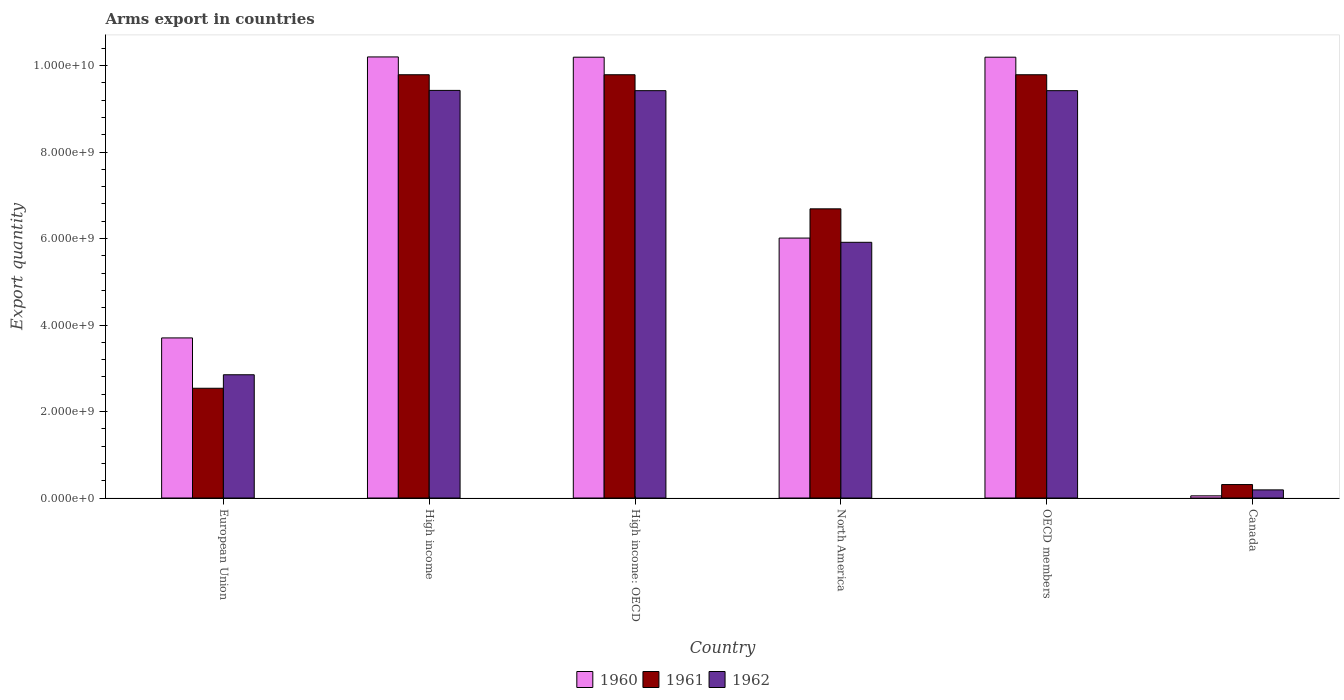How many groups of bars are there?
Offer a terse response. 6. Are the number of bars on each tick of the X-axis equal?
Provide a succinct answer. Yes. How many bars are there on the 2nd tick from the right?
Provide a succinct answer. 3. What is the label of the 3rd group of bars from the left?
Your answer should be compact. High income: OECD. In how many cases, is the number of bars for a given country not equal to the number of legend labels?
Provide a short and direct response. 0. What is the total arms export in 1961 in High income?
Offer a very short reply. 9.79e+09. Across all countries, what is the maximum total arms export in 1962?
Your answer should be compact. 9.43e+09. Across all countries, what is the minimum total arms export in 1961?
Your response must be concise. 3.11e+08. What is the total total arms export in 1960 in the graph?
Give a very brief answer. 4.04e+1. What is the difference between the total arms export in 1962 in High income: OECD and that in OECD members?
Provide a succinct answer. 0. What is the difference between the total arms export in 1960 in High income: OECD and the total arms export in 1961 in High income?
Offer a terse response. 4.06e+08. What is the average total arms export in 1960 per country?
Your answer should be compact. 6.73e+09. What is the difference between the total arms export of/in 1962 and total arms export of/in 1960 in North America?
Keep it short and to the point. -9.80e+07. In how many countries, is the total arms export in 1961 greater than 4400000000?
Ensure brevity in your answer.  4. What is the ratio of the total arms export in 1961 in High income to that in High income: OECD?
Give a very brief answer. 1. Is the difference between the total arms export in 1962 in High income and North America greater than the difference between the total arms export in 1960 in High income and North America?
Ensure brevity in your answer.  No. What is the difference between the highest and the lowest total arms export in 1960?
Offer a terse response. 1.02e+1. In how many countries, is the total arms export in 1962 greater than the average total arms export in 1962 taken over all countries?
Make the answer very short. 3. Is the sum of the total arms export in 1960 in European Union and OECD members greater than the maximum total arms export in 1962 across all countries?
Offer a terse response. Yes. What does the 3rd bar from the right in High income: OECD represents?
Keep it short and to the point. 1960. How many bars are there?
Your answer should be compact. 18. Does the graph contain any zero values?
Make the answer very short. No. Does the graph contain grids?
Offer a very short reply. No. Where does the legend appear in the graph?
Your response must be concise. Bottom center. How many legend labels are there?
Offer a very short reply. 3. What is the title of the graph?
Provide a short and direct response. Arms export in countries. Does "1991" appear as one of the legend labels in the graph?
Provide a short and direct response. No. What is the label or title of the Y-axis?
Your answer should be compact. Export quantity. What is the Export quantity in 1960 in European Union?
Provide a succinct answer. 3.70e+09. What is the Export quantity in 1961 in European Union?
Make the answer very short. 2.54e+09. What is the Export quantity in 1962 in European Union?
Provide a succinct answer. 2.85e+09. What is the Export quantity of 1960 in High income?
Provide a succinct answer. 1.02e+1. What is the Export quantity of 1961 in High income?
Make the answer very short. 9.79e+09. What is the Export quantity of 1962 in High income?
Make the answer very short. 9.43e+09. What is the Export quantity of 1960 in High income: OECD?
Your response must be concise. 1.02e+1. What is the Export quantity of 1961 in High income: OECD?
Provide a short and direct response. 9.79e+09. What is the Export quantity in 1962 in High income: OECD?
Make the answer very short. 9.42e+09. What is the Export quantity in 1960 in North America?
Your response must be concise. 6.01e+09. What is the Export quantity in 1961 in North America?
Provide a short and direct response. 6.69e+09. What is the Export quantity of 1962 in North America?
Provide a succinct answer. 5.91e+09. What is the Export quantity in 1960 in OECD members?
Your response must be concise. 1.02e+1. What is the Export quantity in 1961 in OECD members?
Your response must be concise. 9.79e+09. What is the Export quantity in 1962 in OECD members?
Keep it short and to the point. 9.42e+09. What is the Export quantity of 1960 in Canada?
Make the answer very short. 5.00e+07. What is the Export quantity in 1961 in Canada?
Ensure brevity in your answer.  3.11e+08. What is the Export quantity in 1962 in Canada?
Provide a succinct answer. 1.88e+08. Across all countries, what is the maximum Export quantity in 1960?
Offer a terse response. 1.02e+1. Across all countries, what is the maximum Export quantity of 1961?
Provide a succinct answer. 9.79e+09. Across all countries, what is the maximum Export quantity in 1962?
Give a very brief answer. 9.43e+09. Across all countries, what is the minimum Export quantity in 1961?
Ensure brevity in your answer.  3.11e+08. Across all countries, what is the minimum Export quantity of 1962?
Offer a terse response. 1.88e+08. What is the total Export quantity of 1960 in the graph?
Your answer should be compact. 4.04e+1. What is the total Export quantity in 1961 in the graph?
Provide a succinct answer. 3.89e+1. What is the total Export quantity of 1962 in the graph?
Ensure brevity in your answer.  3.72e+1. What is the difference between the Export quantity in 1960 in European Union and that in High income?
Make the answer very short. -6.50e+09. What is the difference between the Export quantity of 1961 in European Union and that in High income?
Keep it short and to the point. -7.25e+09. What is the difference between the Export quantity in 1962 in European Union and that in High income?
Provide a short and direct response. -6.58e+09. What is the difference between the Export quantity of 1960 in European Union and that in High income: OECD?
Your response must be concise. -6.49e+09. What is the difference between the Export quantity in 1961 in European Union and that in High income: OECD?
Your response must be concise. -7.25e+09. What is the difference between the Export quantity of 1962 in European Union and that in High income: OECD?
Provide a succinct answer. -6.57e+09. What is the difference between the Export quantity in 1960 in European Union and that in North America?
Your answer should be compact. -2.31e+09. What is the difference between the Export quantity in 1961 in European Union and that in North America?
Provide a short and direct response. -4.15e+09. What is the difference between the Export quantity in 1962 in European Union and that in North America?
Provide a short and direct response. -3.06e+09. What is the difference between the Export quantity in 1960 in European Union and that in OECD members?
Your answer should be very brief. -6.49e+09. What is the difference between the Export quantity of 1961 in European Union and that in OECD members?
Your answer should be very brief. -7.25e+09. What is the difference between the Export quantity in 1962 in European Union and that in OECD members?
Provide a short and direct response. -6.57e+09. What is the difference between the Export quantity in 1960 in European Union and that in Canada?
Provide a short and direct response. 3.65e+09. What is the difference between the Export quantity in 1961 in European Union and that in Canada?
Your response must be concise. 2.23e+09. What is the difference between the Export quantity in 1962 in European Union and that in Canada?
Ensure brevity in your answer.  2.66e+09. What is the difference between the Export quantity in 1960 in High income and that in High income: OECD?
Make the answer very short. 6.00e+06. What is the difference between the Export quantity in 1961 in High income and that in High income: OECD?
Offer a very short reply. 0. What is the difference between the Export quantity of 1960 in High income and that in North America?
Make the answer very short. 4.19e+09. What is the difference between the Export quantity in 1961 in High income and that in North America?
Offer a very short reply. 3.10e+09. What is the difference between the Export quantity in 1962 in High income and that in North America?
Keep it short and to the point. 3.51e+09. What is the difference between the Export quantity in 1961 in High income and that in OECD members?
Your answer should be compact. 0. What is the difference between the Export quantity in 1962 in High income and that in OECD members?
Ensure brevity in your answer.  6.00e+06. What is the difference between the Export quantity of 1960 in High income and that in Canada?
Your response must be concise. 1.02e+1. What is the difference between the Export quantity of 1961 in High income and that in Canada?
Ensure brevity in your answer.  9.48e+09. What is the difference between the Export quantity of 1962 in High income and that in Canada?
Provide a short and direct response. 9.24e+09. What is the difference between the Export quantity of 1960 in High income: OECD and that in North America?
Keep it short and to the point. 4.18e+09. What is the difference between the Export quantity in 1961 in High income: OECD and that in North America?
Keep it short and to the point. 3.10e+09. What is the difference between the Export quantity of 1962 in High income: OECD and that in North America?
Your answer should be very brief. 3.51e+09. What is the difference between the Export quantity of 1960 in High income: OECD and that in Canada?
Provide a succinct answer. 1.01e+1. What is the difference between the Export quantity in 1961 in High income: OECD and that in Canada?
Offer a very short reply. 9.48e+09. What is the difference between the Export quantity of 1962 in High income: OECD and that in Canada?
Offer a terse response. 9.23e+09. What is the difference between the Export quantity of 1960 in North America and that in OECD members?
Offer a very short reply. -4.18e+09. What is the difference between the Export quantity in 1961 in North America and that in OECD members?
Your answer should be compact. -3.10e+09. What is the difference between the Export quantity of 1962 in North America and that in OECD members?
Offer a terse response. -3.51e+09. What is the difference between the Export quantity in 1960 in North America and that in Canada?
Make the answer very short. 5.96e+09. What is the difference between the Export quantity in 1961 in North America and that in Canada?
Your answer should be very brief. 6.38e+09. What is the difference between the Export quantity in 1962 in North America and that in Canada?
Keep it short and to the point. 5.72e+09. What is the difference between the Export quantity of 1960 in OECD members and that in Canada?
Ensure brevity in your answer.  1.01e+1. What is the difference between the Export quantity in 1961 in OECD members and that in Canada?
Keep it short and to the point. 9.48e+09. What is the difference between the Export quantity of 1962 in OECD members and that in Canada?
Offer a terse response. 9.23e+09. What is the difference between the Export quantity of 1960 in European Union and the Export quantity of 1961 in High income?
Your answer should be compact. -6.09e+09. What is the difference between the Export quantity of 1960 in European Union and the Export quantity of 1962 in High income?
Offer a very short reply. -5.72e+09. What is the difference between the Export quantity in 1961 in European Union and the Export quantity in 1962 in High income?
Offer a very short reply. -6.89e+09. What is the difference between the Export quantity in 1960 in European Union and the Export quantity in 1961 in High income: OECD?
Your answer should be very brief. -6.09e+09. What is the difference between the Export quantity in 1960 in European Union and the Export quantity in 1962 in High income: OECD?
Ensure brevity in your answer.  -5.72e+09. What is the difference between the Export quantity of 1961 in European Union and the Export quantity of 1962 in High income: OECD?
Make the answer very short. -6.88e+09. What is the difference between the Export quantity of 1960 in European Union and the Export quantity of 1961 in North America?
Provide a succinct answer. -2.98e+09. What is the difference between the Export quantity in 1960 in European Union and the Export quantity in 1962 in North America?
Provide a short and direct response. -2.21e+09. What is the difference between the Export quantity in 1961 in European Union and the Export quantity in 1962 in North America?
Ensure brevity in your answer.  -3.38e+09. What is the difference between the Export quantity in 1960 in European Union and the Export quantity in 1961 in OECD members?
Your answer should be very brief. -6.09e+09. What is the difference between the Export quantity in 1960 in European Union and the Export quantity in 1962 in OECD members?
Provide a succinct answer. -5.72e+09. What is the difference between the Export quantity of 1961 in European Union and the Export quantity of 1962 in OECD members?
Your answer should be compact. -6.88e+09. What is the difference between the Export quantity of 1960 in European Union and the Export quantity of 1961 in Canada?
Make the answer very short. 3.39e+09. What is the difference between the Export quantity in 1960 in European Union and the Export quantity in 1962 in Canada?
Make the answer very short. 3.51e+09. What is the difference between the Export quantity of 1961 in European Union and the Export quantity of 1962 in Canada?
Your answer should be compact. 2.35e+09. What is the difference between the Export quantity of 1960 in High income and the Export quantity of 1961 in High income: OECD?
Provide a short and direct response. 4.12e+08. What is the difference between the Export quantity of 1960 in High income and the Export quantity of 1962 in High income: OECD?
Your answer should be very brief. 7.80e+08. What is the difference between the Export quantity of 1961 in High income and the Export quantity of 1962 in High income: OECD?
Give a very brief answer. 3.68e+08. What is the difference between the Export quantity of 1960 in High income and the Export quantity of 1961 in North America?
Offer a very short reply. 3.51e+09. What is the difference between the Export quantity in 1960 in High income and the Export quantity in 1962 in North America?
Provide a succinct answer. 4.29e+09. What is the difference between the Export quantity in 1961 in High income and the Export quantity in 1962 in North America?
Keep it short and to the point. 3.88e+09. What is the difference between the Export quantity in 1960 in High income and the Export quantity in 1961 in OECD members?
Give a very brief answer. 4.12e+08. What is the difference between the Export quantity in 1960 in High income and the Export quantity in 1962 in OECD members?
Your answer should be very brief. 7.80e+08. What is the difference between the Export quantity in 1961 in High income and the Export quantity in 1962 in OECD members?
Ensure brevity in your answer.  3.68e+08. What is the difference between the Export quantity of 1960 in High income and the Export quantity of 1961 in Canada?
Your response must be concise. 9.89e+09. What is the difference between the Export quantity of 1960 in High income and the Export quantity of 1962 in Canada?
Make the answer very short. 1.00e+1. What is the difference between the Export quantity in 1961 in High income and the Export quantity in 1962 in Canada?
Provide a succinct answer. 9.60e+09. What is the difference between the Export quantity in 1960 in High income: OECD and the Export quantity in 1961 in North America?
Make the answer very short. 3.51e+09. What is the difference between the Export quantity of 1960 in High income: OECD and the Export quantity of 1962 in North America?
Give a very brief answer. 4.28e+09. What is the difference between the Export quantity in 1961 in High income: OECD and the Export quantity in 1962 in North America?
Offer a terse response. 3.88e+09. What is the difference between the Export quantity of 1960 in High income: OECD and the Export quantity of 1961 in OECD members?
Give a very brief answer. 4.06e+08. What is the difference between the Export quantity of 1960 in High income: OECD and the Export quantity of 1962 in OECD members?
Your answer should be very brief. 7.74e+08. What is the difference between the Export quantity of 1961 in High income: OECD and the Export quantity of 1962 in OECD members?
Provide a short and direct response. 3.68e+08. What is the difference between the Export quantity in 1960 in High income: OECD and the Export quantity in 1961 in Canada?
Your answer should be compact. 9.88e+09. What is the difference between the Export quantity of 1960 in High income: OECD and the Export quantity of 1962 in Canada?
Ensure brevity in your answer.  1.00e+1. What is the difference between the Export quantity of 1961 in High income: OECD and the Export quantity of 1962 in Canada?
Your response must be concise. 9.60e+09. What is the difference between the Export quantity in 1960 in North America and the Export quantity in 1961 in OECD members?
Your answer should be compact. -3.78e+09. What is the difference between the Export quantity in 1960 in North America and the Export quantity in 1962 in OECD members?
Offer a very short reply. -3.41e+09. What is the difference between the Export quantity in 1961 in North America and the Export quantity in 1962 in OECD members?
Keep it short and to the point. -2.73e+09. What is the difference between the Export quantity of 1960 in North America and the Export quantity of 1961 in Canada?
Provide a succinct answer. 5.70e+09. What is the difference between the Export quantity in 1960 in North America and the Export quantity in 1962 in Canada?
Provide a succinct answer. 5.82e+09. What is the difference between the Export quantity of 1961 in North America and the Export quantity of 1962 in Canada?
Provide a short and direct response. 6.50e+09. What is the difference between the Export quantity in 1960 in OECD members and the Export quantity in 1961 in Canada?
Provide a succinct answer. 9.88e+09. What is the difference between the Export quantity in 1960 in OECD members and the Export quantity in 1962 in Canada?
Offer a very short reply. 1.00e+1. What is the difference between the Export quantity of 1961 in OECD members and the Export quantity of 1962 in Canada?
Your answer should be compact. 9.60e+09. What is the average Export quantity in 1960 per country?
Provide a short and direct response. 6.73e+09. What is the average Export quantity of 1961 per country?
Provide a succinct answer. 6.48e+09. What is the average Export quantity of 1962 per country?
Keep it short and to the point. 6.20e+09. What is the difference between the Export quantity of 1960 and Export quantity of 1961 in European Union?
Provide a succinct answer. 1.16e+09. What is the difference between the Export quantity in 1960 and Export quantity in 1962 in European Union?
Keep it short and to the point. 8.52e+08. What is the difference between the Export quantity in 1961 and Export quantity in 1962 in European Union?
Make the answer very short. -3.12e+08. What is the difference between the Export quantity in 1960 and Export quantity in 1961 in High income?
Your answer should be very brief. 4.12e+08. What is the difference between the Export quantity of 1960 and Export quantity of 1962 in High income?
Make the answer very short. 7.74e+08. What is the difference between the Export quantity of 1961 and Export quantity of 1962 in High income?
Your response must be concise. 3.62e+08. What is the difference between the Export quantity in 1960 and Export quantity in 1961 in High income: OECD?
Your response must be concise. 4.06e+08. What is the difference between the Export quantity of 1960 and Export quantity of 1962 in High income: OECD?
Ensure brevity in your answer.  7.74e+08. What is the difference between the Export quantity in 1961 and Export quantity in 1962 in High income: OECD?
Provide a succinct answer. 3.68e+08. What is the difference between the Export quantity in 1960 and Export quantity in 1961 in North America?
Your answer should be compact. -6.76e+08. What is the difference between the Export quantity of 1960 and Export quantity of 1962 in North America?
Your answer should be very brief. 9.80e+07. What is the difference between the Export quantity in 1961 and Export quantity in 1962 in North America?
Offer a very short reply. 7.74e+08. What is the difference between the Export quantity of 1960 and Export quantity of 1961 in OECD members?
Your answer should be very brief. 4.06e+08. What is the difference between the Export quantity of 1960 and Export quantity of 1962 in OECD members?
Make the answer very short. 7.74e+08. What is the difference between the Export quantity of 1961 and Export quantity of 1962 in OECD members?
Provide a succinct answer. 3.68e+08. What is the difference between the Export quantity in 1960 and Export quantity in 1961 in Canada?
Your answer should be compact. -2.61e+08. What is the difference between the Export quantity of 1960 and Export quantity of 1962 in Canada?
Offer a terse response. -1.38e+08. What is the difference between the Export quantity of 1961 and Export quantity of 1962 in Canada?
Keep it short and to the point. 1.23e+08. What is the ratio of the Export quantity of 1960 in European Union to that in High income?
Provide a short and direct response. 0.36. What is the ratio of the Export quantity of 1961 in European Union to that in High income?
Offer a very short reply. 0.26. What is the ratio of the Export quantity in 1962 in European Union to that in High income?
Your response must be concise. 0.3. What is the ratio of the Export quantity of 1960 in European Union to that in High income: OECD?
Give a very brief answer. 0.36. What is the ratio of the Export quantity in 1961 in European Union to that in High income: OECD?
Give a very brief answer. 0.26. What is the ratio of the Export quantity in 1962 in European Union to that in High income: OECD?
Your answer should be very brief. 0.3. What is the ratio of the Export quantity in 1960 in European Union to that in North America?
Provide a succinct answer. 0.62. What is the ratio of the Export quantity of 1961 in European Union to that in North America?
Make the answer very short. 0.38. What is the ratio of the Export quantity of 1962 in European Union to that in North America?
Provide a short and direct response. 0.48. What is the ratio of the Export quantity of 1960 in European Union to that in OECD members?
Provide a succinct answer. 0.36. What is the ratio of the Export quantity in 1961 in European Union to that in OECD members?
Offer a very short reply. 0.26. What is the ratio of the Export quantity of 1962 in European Union to that in OECD members?
Give a very brief answer. 0.3. What is the ratio of the Export quantity in 1960 in European Union to that in Canada?
Offer a very short reply. 74.04. What is the ratio of the Export quantity of 1961 in European Union to that in Canada?
Provide a short and direct response. 8.16. What is the ratio of the Export quantity in 1962 in European Union to that in Canada?
Your response must be concise. 15.16. What is the ratio of the Export quantity in 1961 in High income to that in High income: OECD?
Provide a short and direct response. 1. What is the ratio of the Export quantity of 1962 in High income to that in High income: OECD?
Give a very brief answer. 1. What is the ratio of the Export quantity in 1960 in High income to that in North America?
Provide a short and direct response. 1.7. What is the ratio of the Export quantity in 1961 in High income to that in North America?
Ensure brevity in your answer.  1.46. What is the ratio of the Export quantity in 1962 in High income to that in North America?
Keep it short and to the point. 1.59. What is the ratio of the Export quantity in 1962 in High income to that in OECD members?
Your response must be concise. 1. What is the ratio of the Export quantity in 1960 in High income to that in Canada?
Keep it short and to the point. 204. What is the ratio of the Export quantity in 1961 in High income to that in Canada?
Your response must be concise. 31.47. What is the ratio of the Export quantity in 1962 in High income to that in Canada?
Provide a succinct answer. 50.14. What is the ratio of the Export quantity of 1960 in High income: OECD to that in North America?
Provide a short and direct response. 1.7. What is the ratio of the Export quantity of 1961 in High income: OECD to that in North America?
Offer a very short reply. 1.46. What is the ratio of the Export quantity in 1962 in High income: OECD to that in North America?
Provide a short and direct response. 1.59. What is the ratio of the Export quantity of 1962 in High income: OECD to that in OECD members?
Your response must be concise. 1. What is the ratio of the Export quantity in 1960 in High income: OECD to that in Canada?
Keep it short and to the point. 203.88. What is the ratio of the Export quantity of 1961 in High income: OECD to that in Canada?
Offer a very short reply. 31.47. What is the ratio of the Export quantity in 1962 in High income: OECD to that in Canada?
Offer a very short reply. 50.11. What is the ratio of the Export quantity of 1960 in North America to that in OECD members?
Provide a succinct answer. 0.59. What is the ratio of the Export quantity in 1961 in North America to that in OECD members?
Provide a short and direct response. 0.68. What is the ratio of the Export quantity in 1962 in North America to that in OECD members?
Keep it short and to the point. 0.63. What is the ratio of the Export quantity of 1960 in North America to that in Canada?
Your response must be concise. 120.22. What is the ratio of the Export quantity of 1961 in North America to that in Canada?
Offer a very short reply. 21.5. What is the ratio of the Export quantity in 1962 in North America to that in Canada?
Offer a very short reply. 31.45. What is the ratio of the Export quantity of 1960 in OECD members to that in Canada?
Your response must be concise. 203.88. What is the ratio of the Export quantity of 1961 in OECD members to that in Canada?
Keep it short and to the point. 31.47. What is the ratio of the Export quantity of 1962 in OECD members to that in Canada?
Your response must be concise. 50.11. What is the difference between the highest and the second highest Export quantity in 1962?
Provide a short and direct response. 6.00e+06. What is the difference between the highest and the lowest Export quantity in 1960?
Your answer should be compact. 1.02e+1. What is the difference between the highest and the lowest Export quantity of 1961?
Keep it short and to the point. 9.48e+09. What is the difference between the highest and the lowest Export quantity of 1962?
Ensure brevity in your answer.  9.24e+09. 